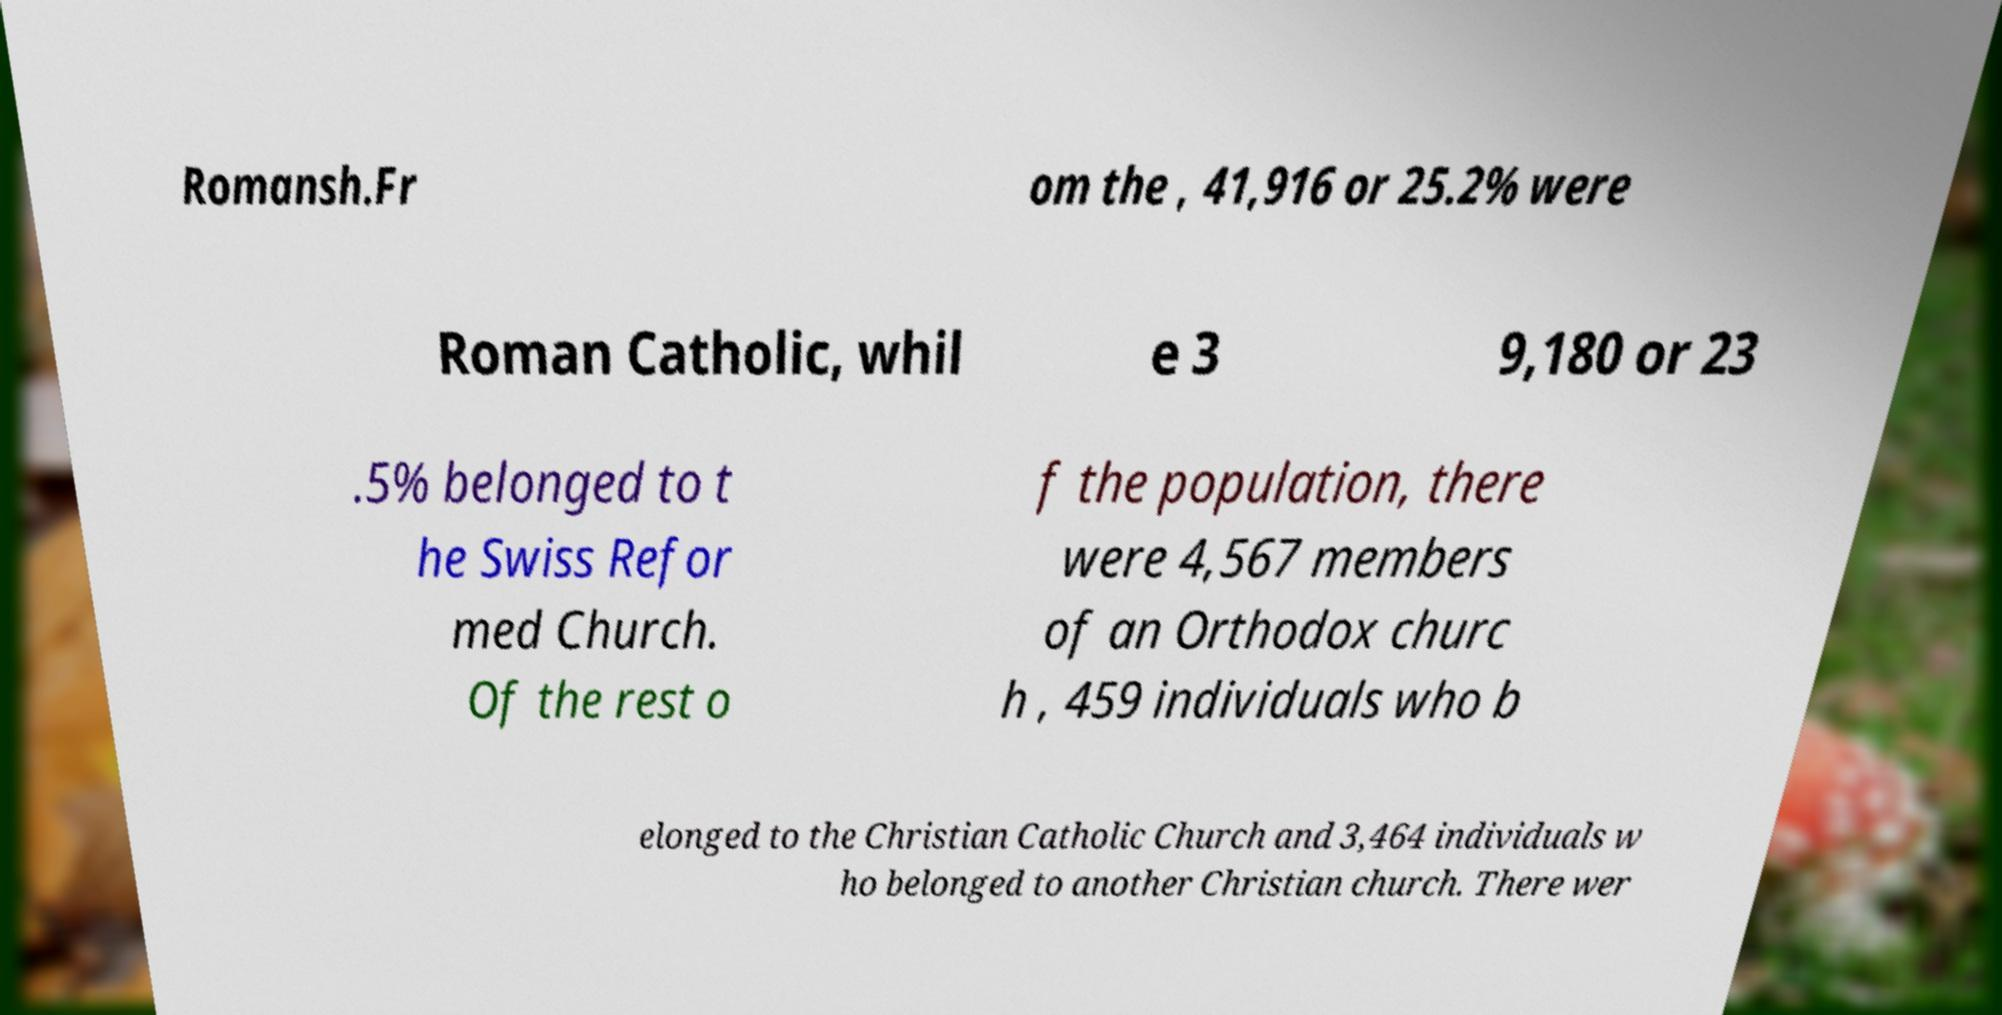What messages or text are displayed in this image? I need them in a readable, typed format. Romansh.Fr om the , 41,916 or 25.2% were Roman Catholic, whil e 3 9,180 or 23 .5% belonged to t he Swiss Refor med Church. Of the rest o f the population, there were 4,567 members of an Orthodox churc h , 459 individuals who b elonged to the Christian Catholic Church and 3,464 individuals w ho belonged to another Christian church. There wer 